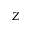Convert formula to latex. <formula><loc_0><loc_0><loc_500><loc_500>Z</formula> 